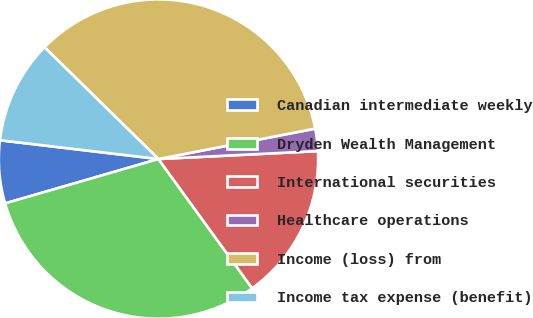Convert chart. <chart><loc_0><loc_0><loc_500><loc_500><pie_chart><fcel>Canadian intermediate weekly<fcel>Dryden Wealth Management<fcel>International securities<fcel>Healthcare operations<fcel>Income (loss) from<fcel>Income tax expense (benefit)<nl><fcel>6.36%<fcel>30.5%<fcel>15.81%<fcel>2.26%<fcel>34.6%<fcel>10.47%<nl></chart> 